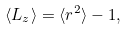<formula> <loc_0><loc_0><loc_500><loc_500>\langle L _ { z } \rangle = \langle r ^ { 2 } \rangle - 1 ,</formula> 